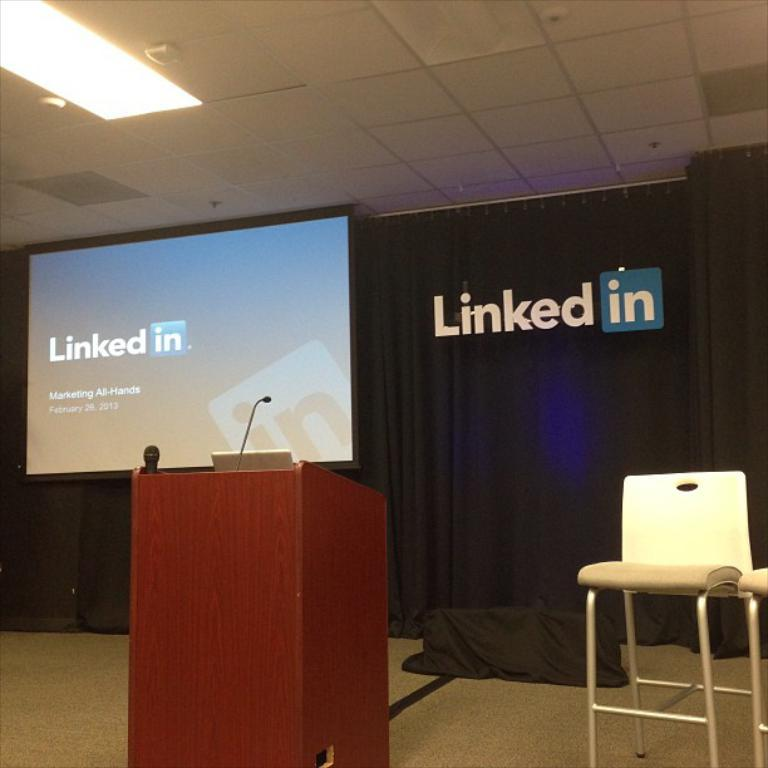What type of furniture is located on the right side of the image? There is a stool on the right side of the image. What can be seen in the middle of the image? There is a podium with a microphone in the middle of the image. What is on the left side of the image? There is a projector screen on the left side of the image. What is the source of light visible at the top of the image? There is a ceiling light visible at the top of the image. How many doors are visible in the image? There are no doors visible in the image. What type of yarn is being used to create the microphone in the image? There is no yarn present in the image; the microphone is attached to a podium. 